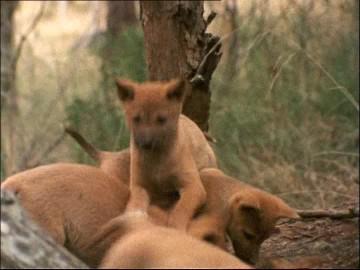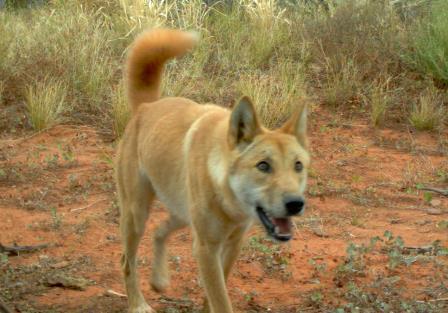The first image is the image on the left, the second image is the image on the right. For the images shown, is this caption "One of the photos shows a wild dog biting another animal." true? Answer yes or no. No. The first image is the image on the left, the second image is the image on the right. Examine the images to the left and right. Is the description "An image shows a wild dog grasping part of another animal with its mouth." accurate? Answer yes or no. No. 